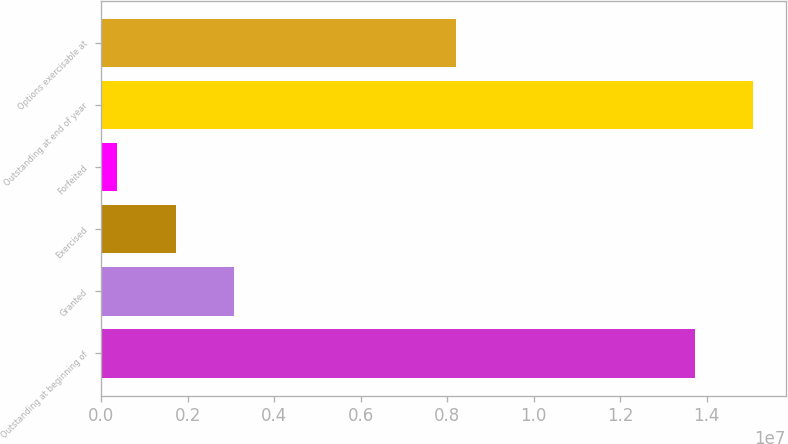<chart> <loc_0><loc_0><loc_500><loc_500><bar_chart><fcel>Outstanding at beginning of<fcel>Granted<fcel>Exercised<fcel>Forfeited<fcel>Outstanding at end of year<fcel>Options exercisable at<nl><fcel>1.37251e+07<fcel>3.07302e+06<fcel>1.72526e+06<fcel>377499<fcel>1.50729e+07<fcel>8.21221e+06<nl></chart> 